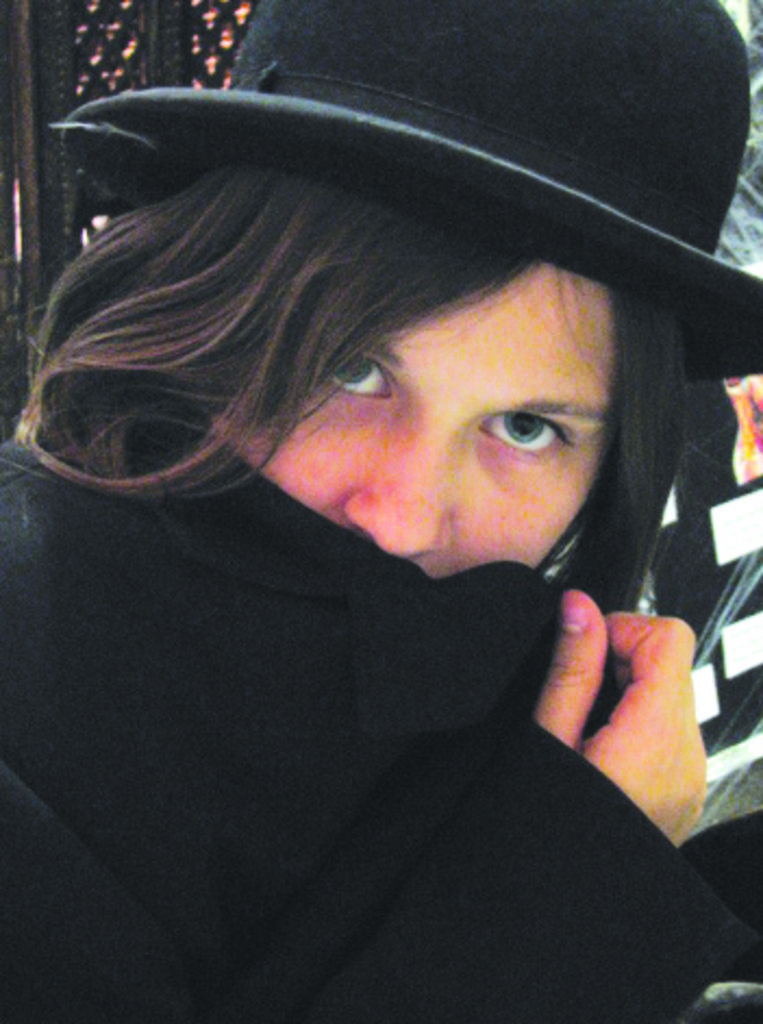What is the main subject of the image? There is a person in the image. What is located behind the person in the image? There is a banner visible behind the person. What type of regret can be seen on the person's face in the image? There is no indication of regret on the person's face in the image. What substance is the person holding in their hand in the image? There is no substance visible in the person's hand in the image. 